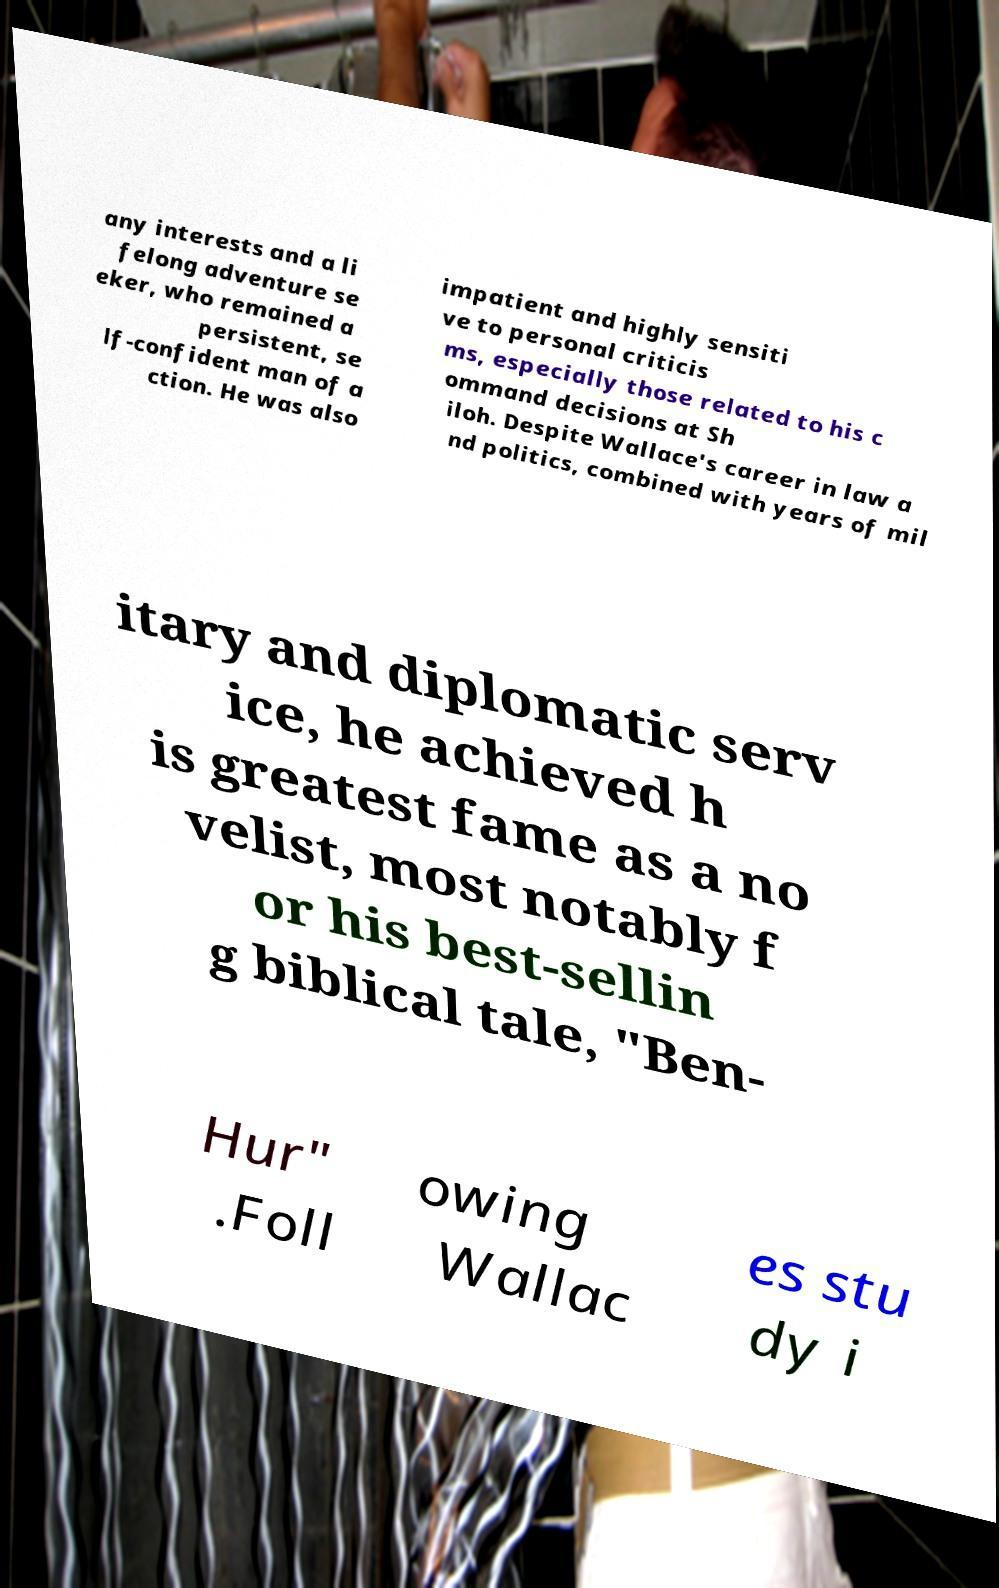What messages or text are displayed in this image? I need them in a readable, typed format. any interests and a li felong adventure se eker, who remained a persistent, se lf-confident man of a ction. He was also impatient and highly sensiti ve to personal criticis ms, especially those related to his c ommand decisions at Sh iloh. Despite Wallace's career in law a nd politics, combined with years of mil itary and diplomatic serv ice, he achieved h is greatest fame as a no velist, most notably f or his best-sellin g biblical tale, "Ben- Hur" .Foll owing Wallac es stu dy i 